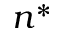Convert formula to latex. <formula><loc_0><loc_0><loc_500><loc_500>n ^ { * }</formula> 